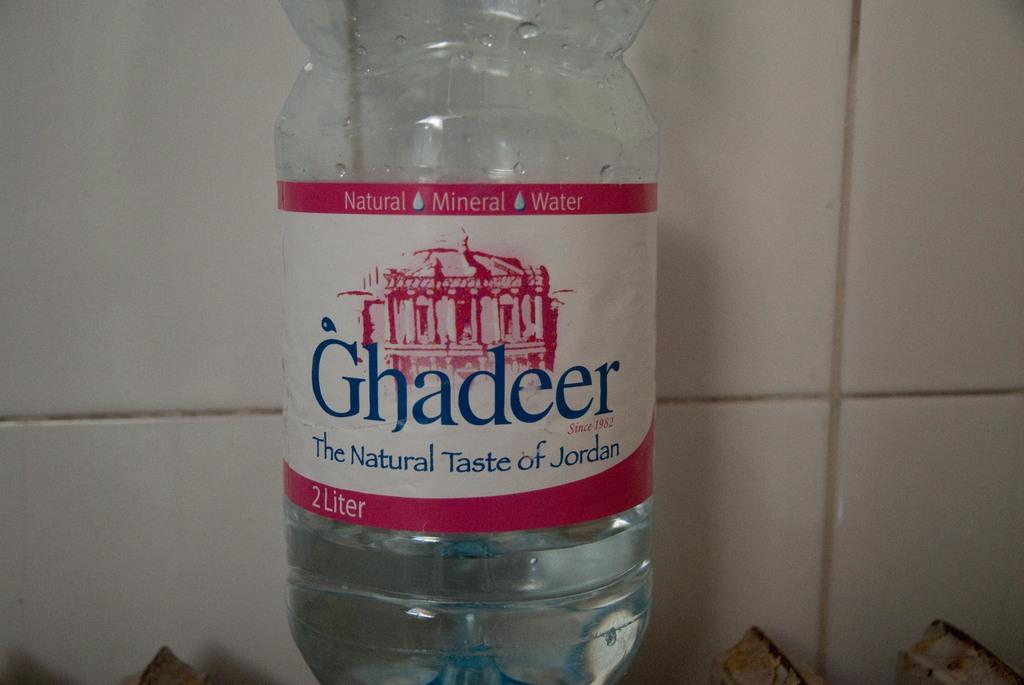What is the object in the image that is used for holding water? There is a water bottle in the image. How do the babies react to the land in the image? There are no babies or land present in the image, so it is not possible to answer that question. 